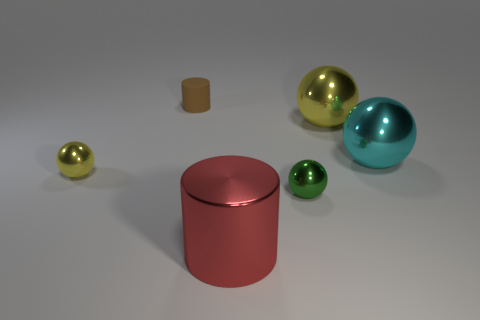The tiny yellow object that is made of the same material as the red cylinder is what shape?
Provide a short and direct response. Sphere. How big is the yellow shiny thing that is to the right of the big metal object in front of the tiny yellow shiny ball?
Ensure brevity in your answer.  Large. How many small objects are either yellow metal things or green metal spheres?
Provide a short and direct response. 2. Is the size of the yellow object in front of the cyan metallic thing the same as the brown matte thing that is behind the red thing?
Provide a succinct answer. Yes. Do the green object and the yellow sphere that is to the right of the large red shiny cylinder have the same material?
Your answer should be very brief. Yes. Are there more yellow things that are left of the tiny green thing than yellow objects to the right of the large cyan metallic ball?
Provide a short and direct response. Yes. What color is the cylinder that is in front of the yellow shiny object that is to the right of the small brown cylinder?
Make the answer very short. Red. What number of spheres are either brown matte things or big metallic things?
Your response must be concise. 2. What number of large metallic things are to the left of the big cyan sphere and behind the small green thing?
Offer a very short reply. 1. What is the color of the tiny metallic ball that is right of the red metal cylinder?
Offer a terse response. Green. 